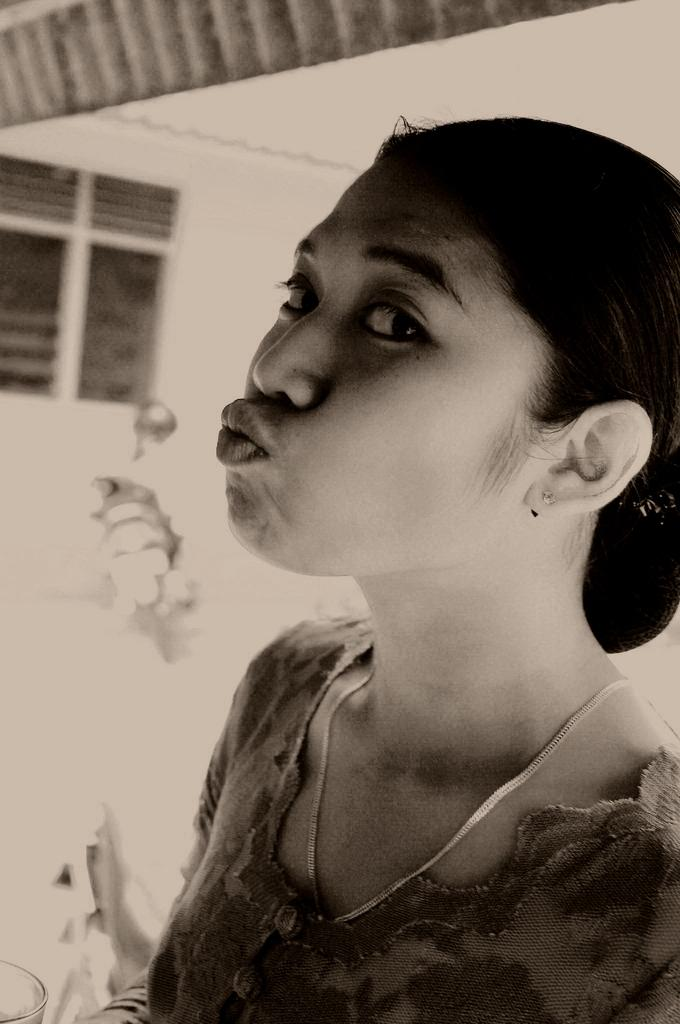What can be observed about the image's appearance? The image appears to be edited. Who is present in the image? There is a woman in the image. What architectural feature can be seen in the image? There are windows in the image. What color is the background of the image? The background of the image is white. What type of nose can be seen on the sofa in the image? There is no sofa present in the image, and therefore no nose can be observed on it. What type of gate is visible in the image? There is no gate present in the image. 